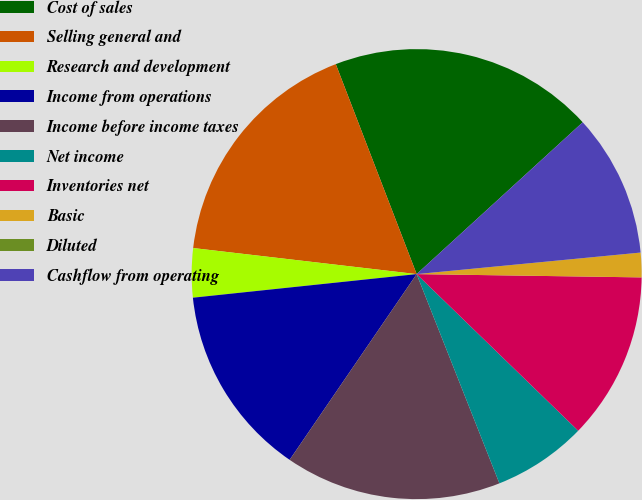Convert chart. <chart><loc_0><loc_0><loc_500><loc_500><pie_chart><fcel>Cost of sales<fcel>Selling general and<fcel>Research and development<fcel>Income from operations<fcel>Income before income taxes<fcel>Net income<fcel>Inventories net<fcel>Basic<fcel>Diluted<fcel>Cashflow from operating<nl><fcel>19.06%<fcel>17.3%<fcel>3.52%<fcel>13.78%<fcel>15.54%<fcel>6.75%<fcel>12.02%<fcel>1.76%<fcel>0.0%<fcel>10.26%<nl></chart> 